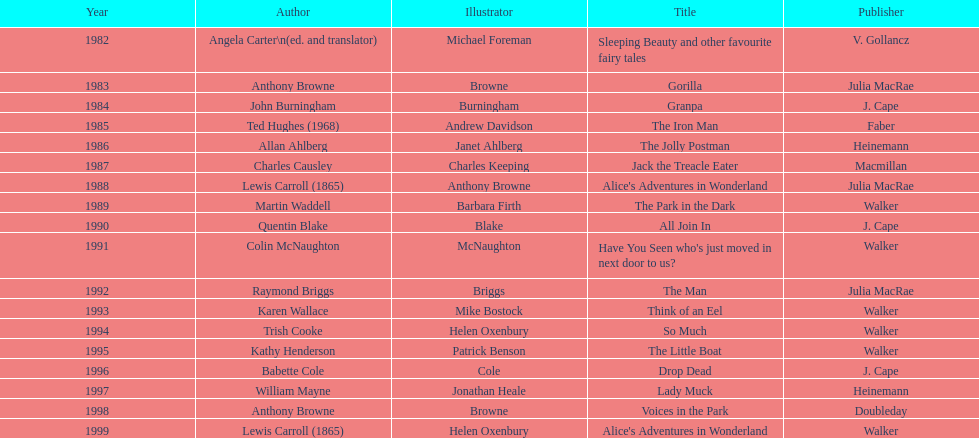How many titles had the same author listed as the illustrator? 7. 